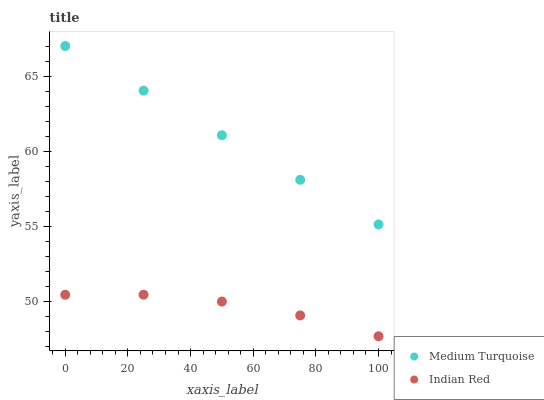Does Indian Red have the minimum area under the curve?
Answer yes or no. Yes. Does Medium Turquoise have the maximum area under the curve?
Answer yes or no. Yes. Does Medium Turquoise have the minimum area under the curve?
Answer yes or no. No. Is Medium Turquoise the smoothest?
Answer yes or no. Yes. Is Indian Red the roughest?
Answer yes or no. Yes. Is Medium Turquoise the roughest?
Answer yes or no. No. Does Indian Red have the lowest value?
Answer yes or no. Yes. Does Medium Turquoise have the lowest value?
Answer yes or no. No. Does Medium Turquoise have the highest value?
Answer yes or no. Yes. Is Indian Red less than Medium Turquoise?
Answer yes or no. Yes. Is Medium Turquoise greater than Indian Red?
Answer yes or no. Yes. Does Indian Red intersect Medium Turquoise?
Answer yes or no. No. 